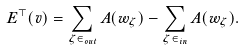<formula> <loc_0><loc_0><loc_500><loc_500>E ^ { \top } ( v ) = \sum _ { \zeta \in \Sigma _ { o u t } } A ( w _ { \zeta } ) - \sum _ { \zeta \in \Sigma _ { i n } } A ( w _ { \zeta } ) .</formula> 